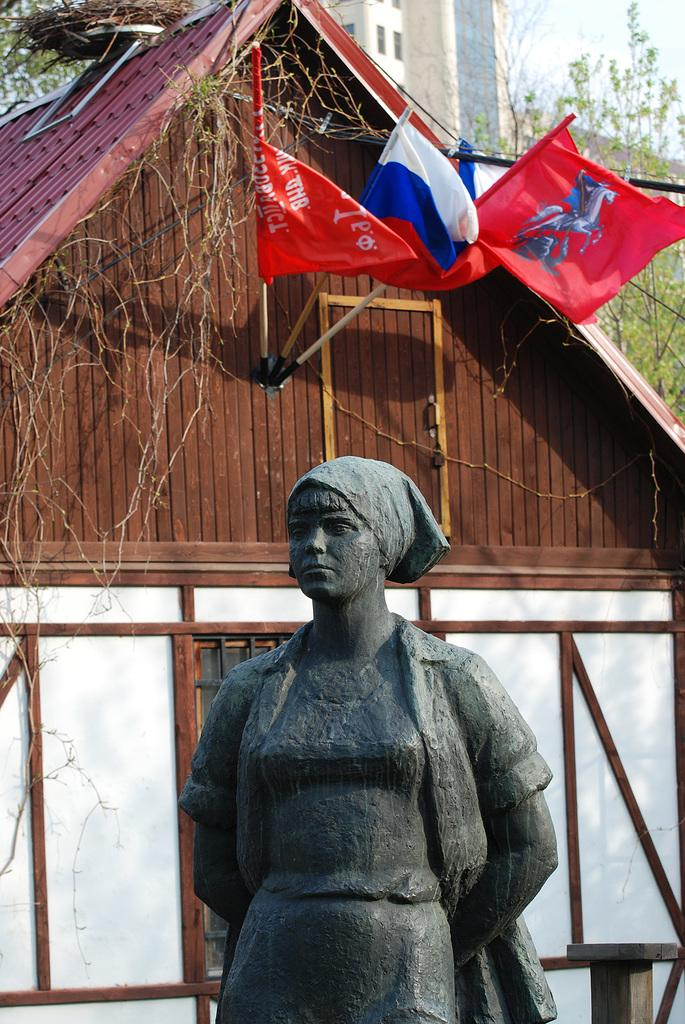What is the main subject of the image? There is a person's statue in the image. What other structures can be seen in the image? There is a house and buildings visible in the image. What type of vegetation is present in the image? There are trees in the image. What can be seen in the background of the image? There are flags, buildings, and the sky visible in the background of the image. When was the image taken? The image was taken during the day. What type of waves can be seen crashing against the statue in the image? There are no waves present in the image; it is a statue surrounded by other structures and elements. What event is taking place in the image? There is no specific event taking place in the image; it is a scene featuring a statue, a house, buildings, trees, flags, and the sky. 